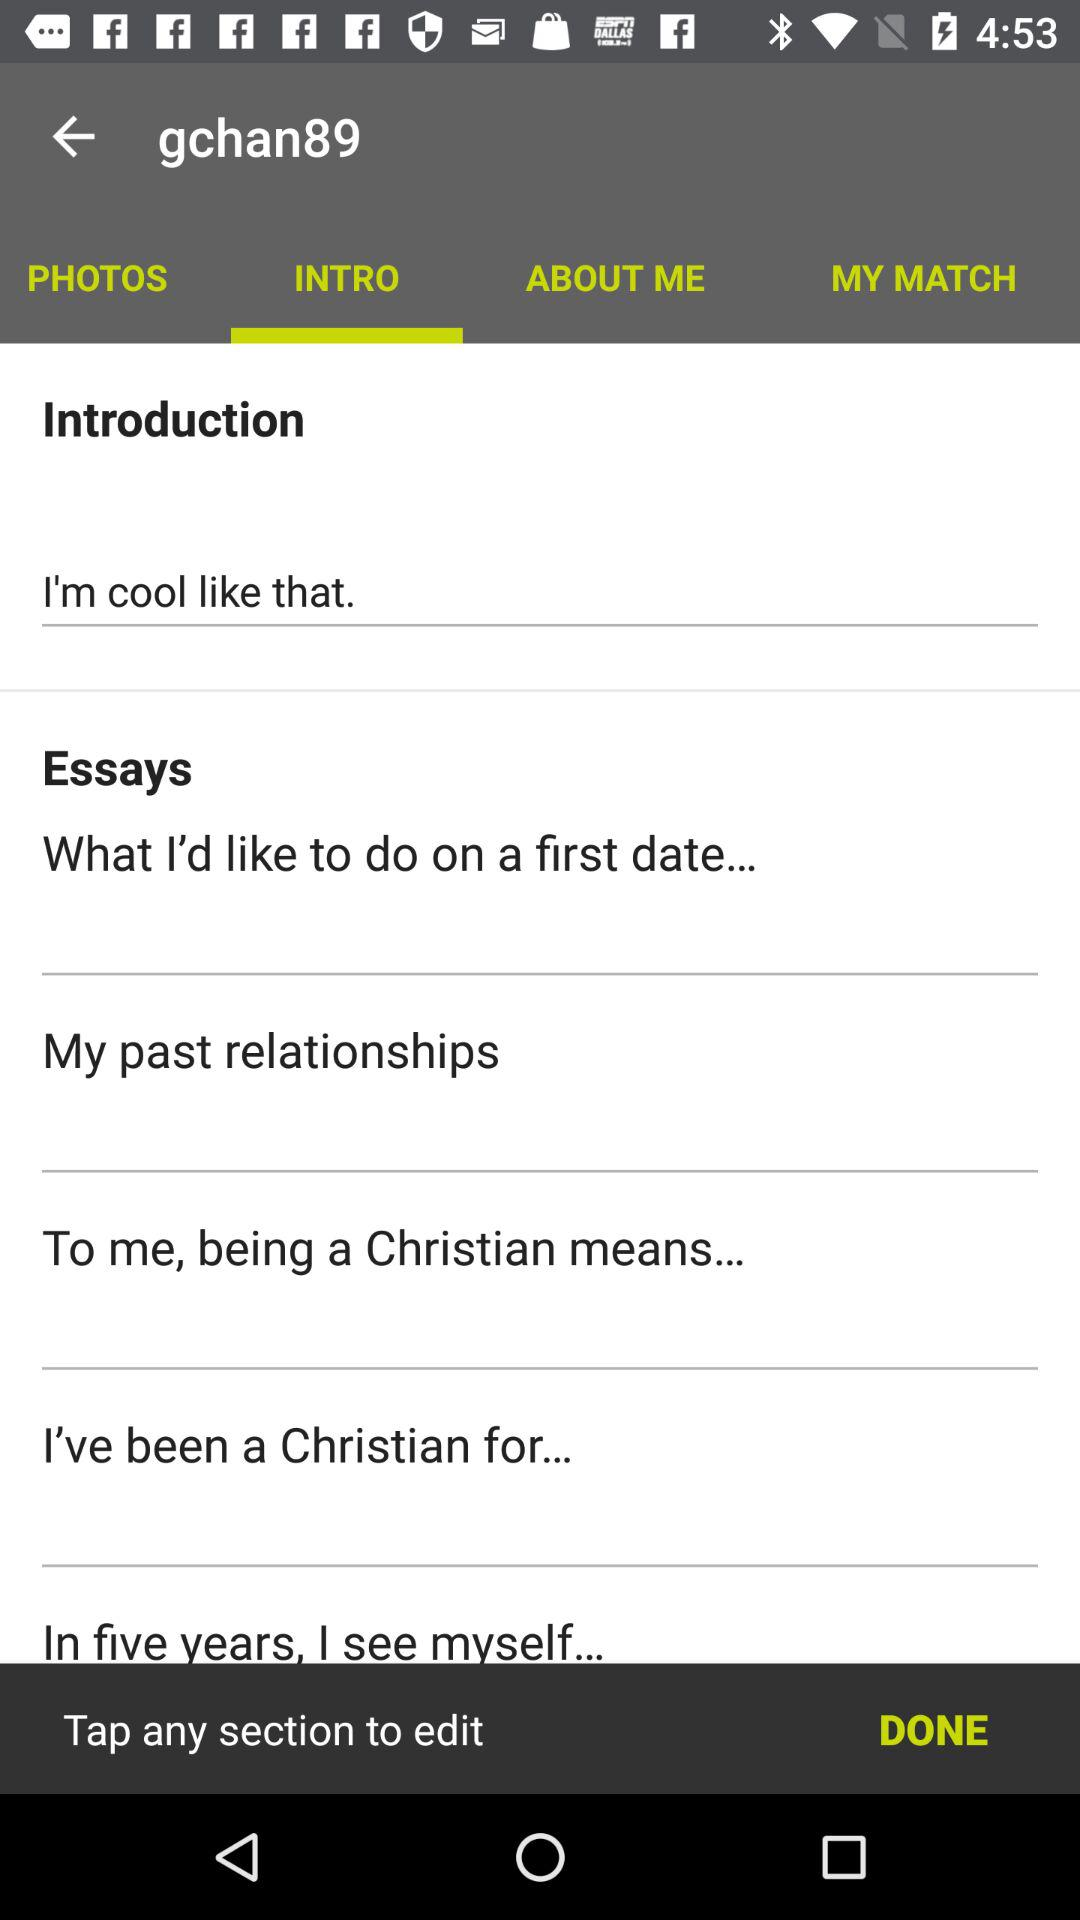What is the username? The username is "gchan89". 